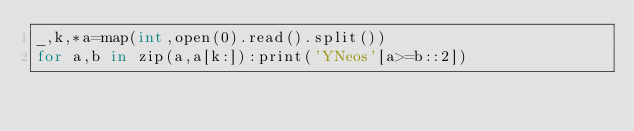<code> <loc_0><loc_0><loc_500><loc_500><_Cython_>_,k,*a=map(int,open(0).read().split())
for a,b in zip(a,a[k:]):print('YNeos'[a>=b::2])</code> 